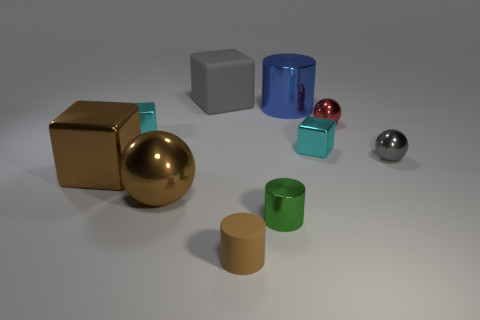Subtract all blocks. How many objects are left? 6 Add 4 tiny spheres. How many tiny spheres are left? 6 Add 2 small gray balls. How many small gray balls exist? 3 Subtract 1 red spheres. How many objects are left? 9 Subtract all brown cylinders. Subtract all tiny green things. How many objects are left? 8 